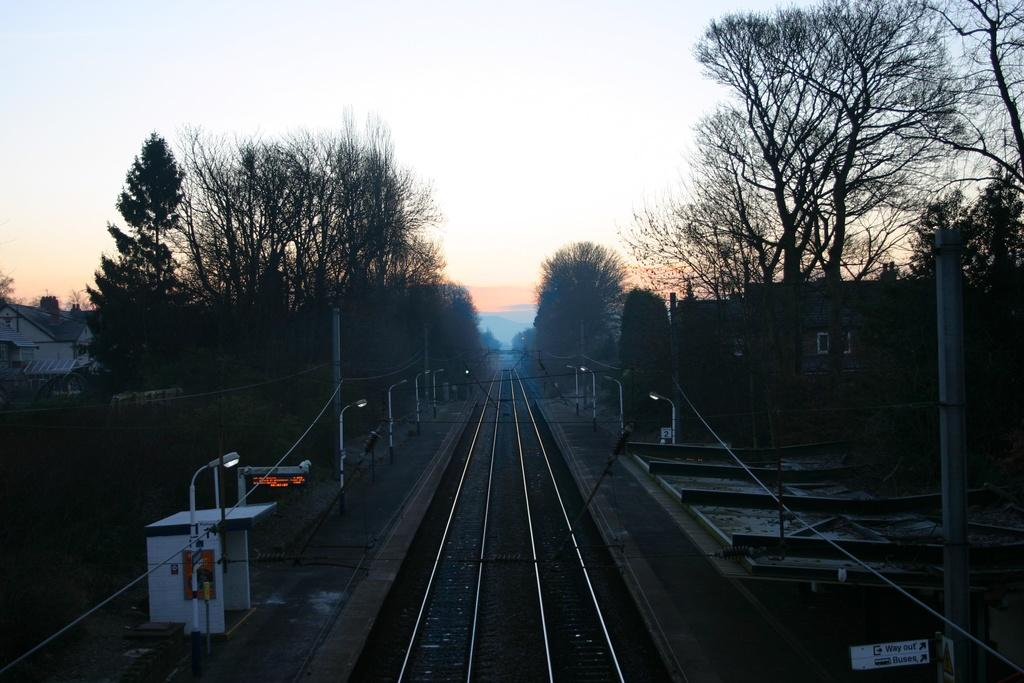What type of transportation infrastructure is shown in the image? There are railway tracks in the image. What structure is present for passengers to wait for trains? There is a platform in the image. What are the light poles used for in the image? The light poles are visible in the image to provide illumination. What are the wires connected to in the image? The wires are present in the image and are connected to the light poles and other electrical infrastructure. What is the pole used for in the image? The pole is present in the image and is likely used to support wires or other infrastructure. What type of shelter is available for passengers in the image? There is a shed in the image for passengers to seek shelter. What type of display is visible in the image? An LED board is visible in the image, which may display train schedules or other information. What type of vegetation is present in the image? Trees are present in the image. What type of residential structures are visible in the image? Houses are visible on either side of the image. What can be seen in the background of the image? The sky is visible in the background of the image. What type of theory is being discussed by the people sitting on the railway tracks in the image? There are no people sitting on the railway tracks in the image, and therefore no theory is being discussed. What type of fork is being used to eat the trees in the image? There are no forks present in the image, and trees are not being eaten. 